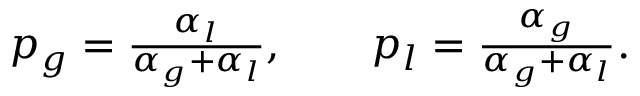Convert formula to latex. <formula><loc_0><loc_0><loc_500><loc_500>\begin{array} { r } { p _ { g } = \frac { \alpha _ { l } } { \alpha _ { g } + \alpha _ { l } } , \quad p _ { l } = \frac { \alpha _ { g } } { \alpha _ { g } + \alpha _ { l } } . } \end{array}</formula> 